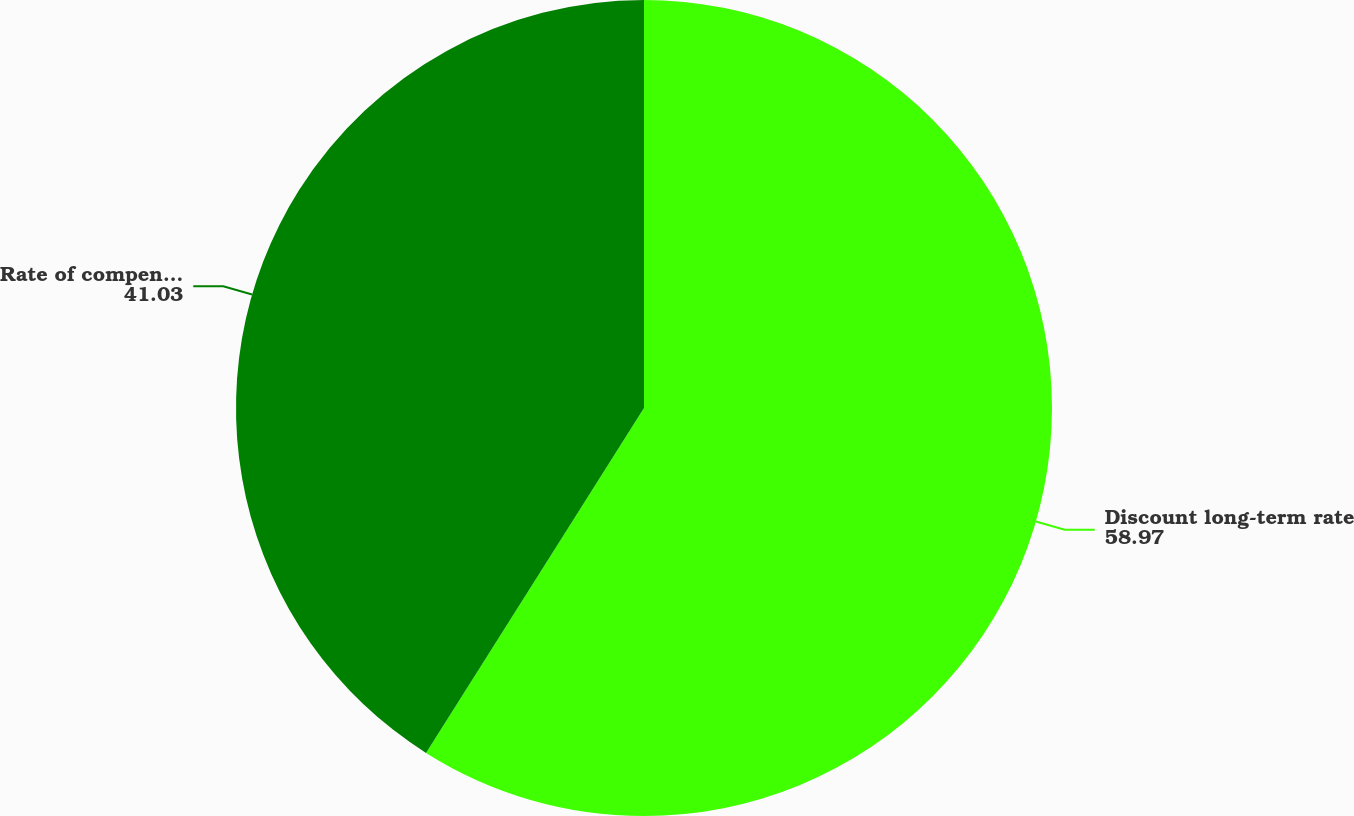Convert chart. <chart><loc_0><loc_0><loc_500><loc_500><pie_chart><fcel>Discount long-term rate<fcel>Rate of compensation increase<nl><fcel>58.97%<fcel>41.03%<nl></chart> 